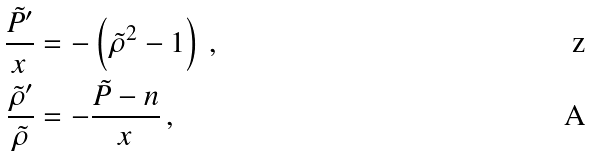Convert formula to latex. <formula><loc_0><loc_0><loc_500><loc_500>\frac { \tilde { P } ^ { \prime } } { x } & = - \left ( \tilde { \rho } ^ { 2 } - 1 \right ) \, , \\ \frac { \tilde { \rho } ^ { \prime } } { \tilde { \rho } } & = - \frac { \tilde { P } - n } { x } \, ,</formula> 